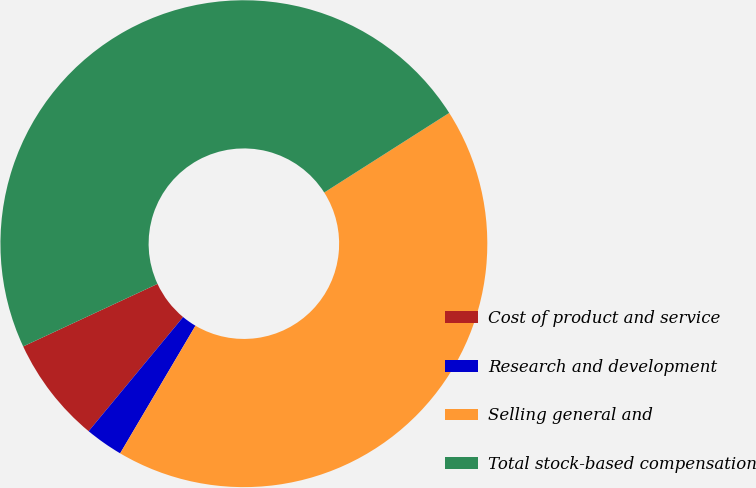<chart> <loc_0><loc_0><loc_500><loc_500><pie_chart><fcel>Cost of product and service<fcel>Research and development<fcel>Selling general and<fcel>Total stock-based compensation<nl><fcel>7.06%<fcel>2.52%<fcel>42.51%<fcel>47.91%<nl></chart> 